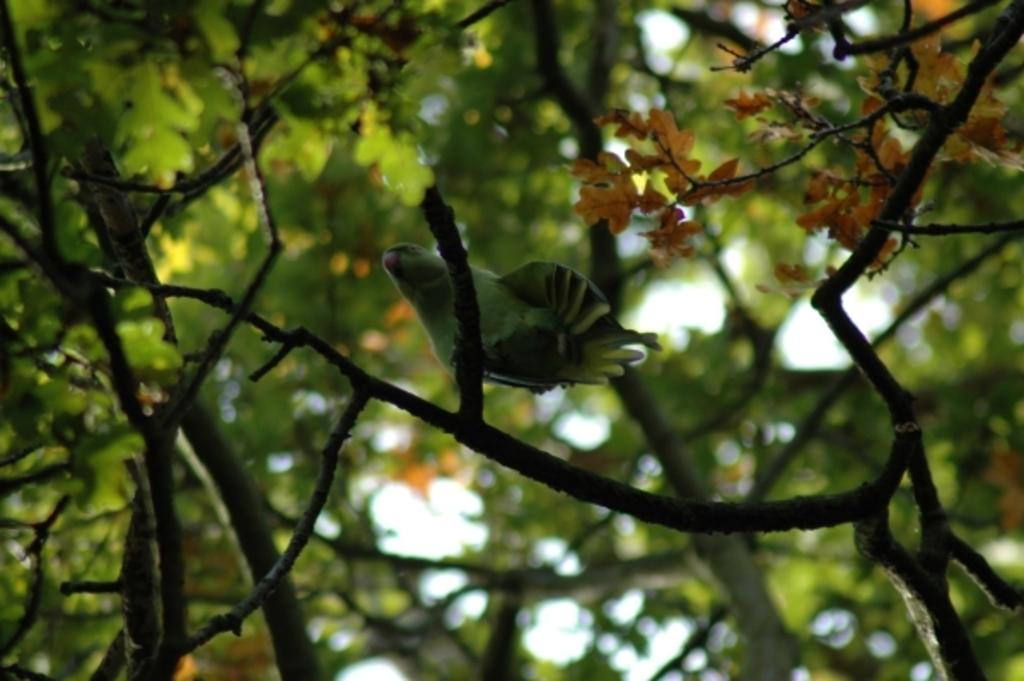What type of animal is in the image? There is a bird in the image. Where is the bird located? The bird is standing on a tree branch. What is the color of the bird? The bird is green in color. What can be seen on the tree besides the bird? There are green leaves and light orange color leaves on the tree. What arithmetic problem is the bird solving in the image? There is no arithmetic problem present in the image; it features a bird standing on a tree branch. Can you see a kite flying in the image? There is no kite present in the image. 